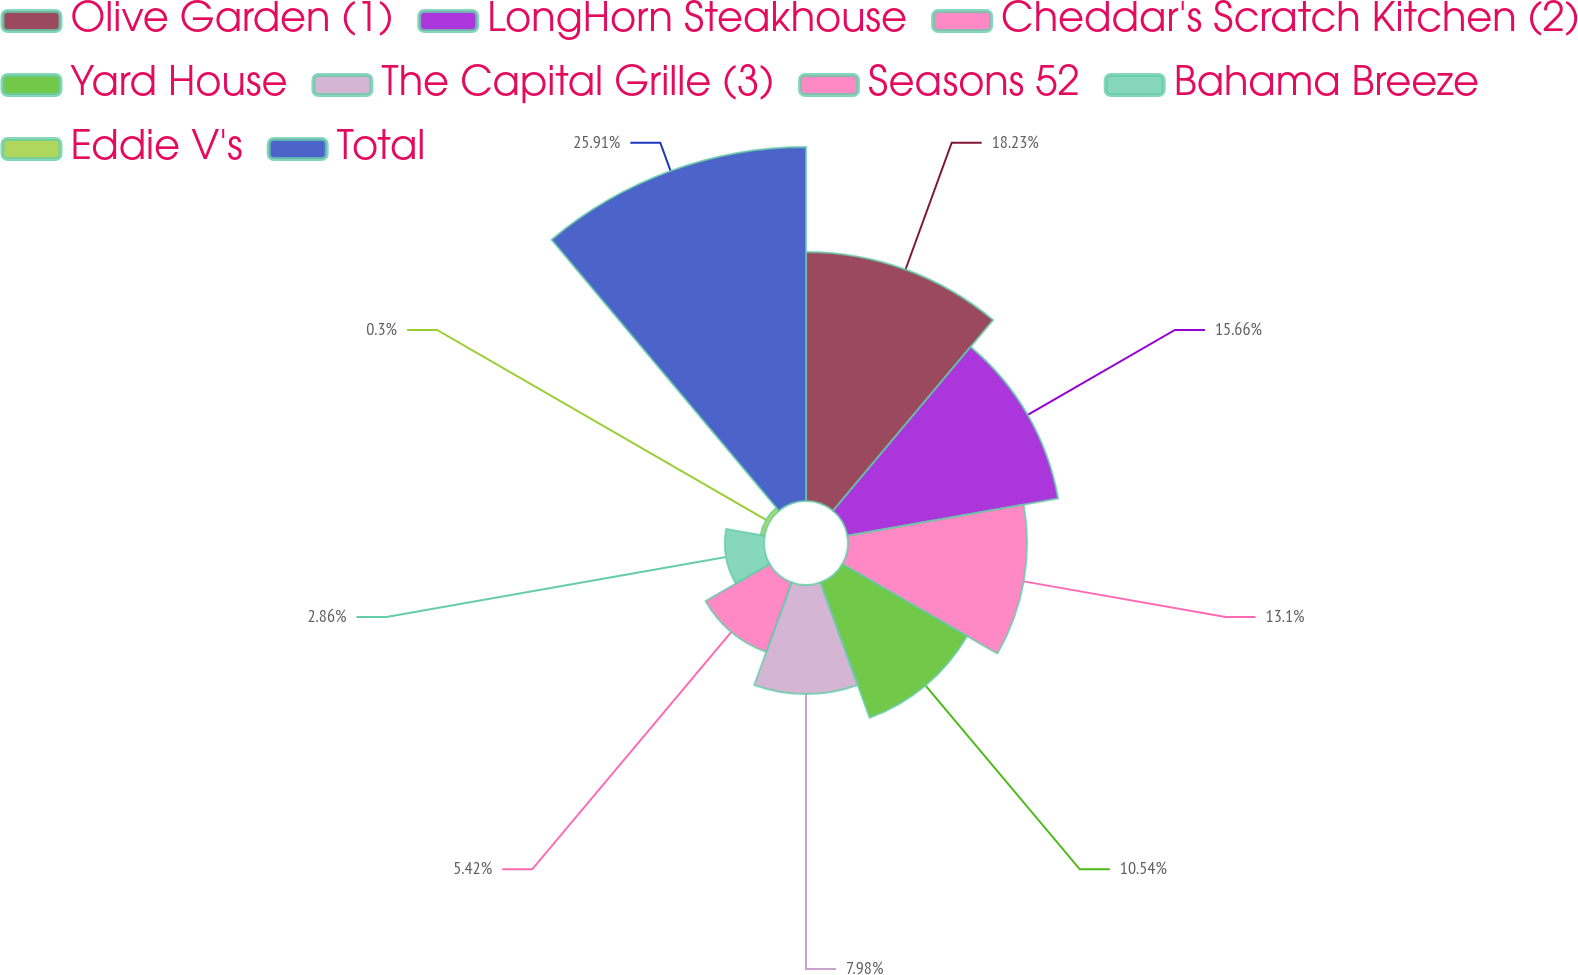Convert chart to OTSL. <chart><loc_0><loc_0><loc_500><loc_500><pie_chart><fcel>Olive Garden (1)<fcel>LongHorn Steakhouse<fcel>Cheddar's Scratch Kitchen (2)<fcel>Yard House<fcel>The Capital Grille (3)<fcel>Seasons 52<fcel>Bahama Breeze<fcel>Eddie V's<fcel>Total<nl><fcel>18.22%<fcel>15.66%<fcel>13.1%<fcel>10.54%<fcel>7.98%<fcel>5.42%<fcel>2.86%<fcel>0.3%<fcel>25.9%<nl></chart> 